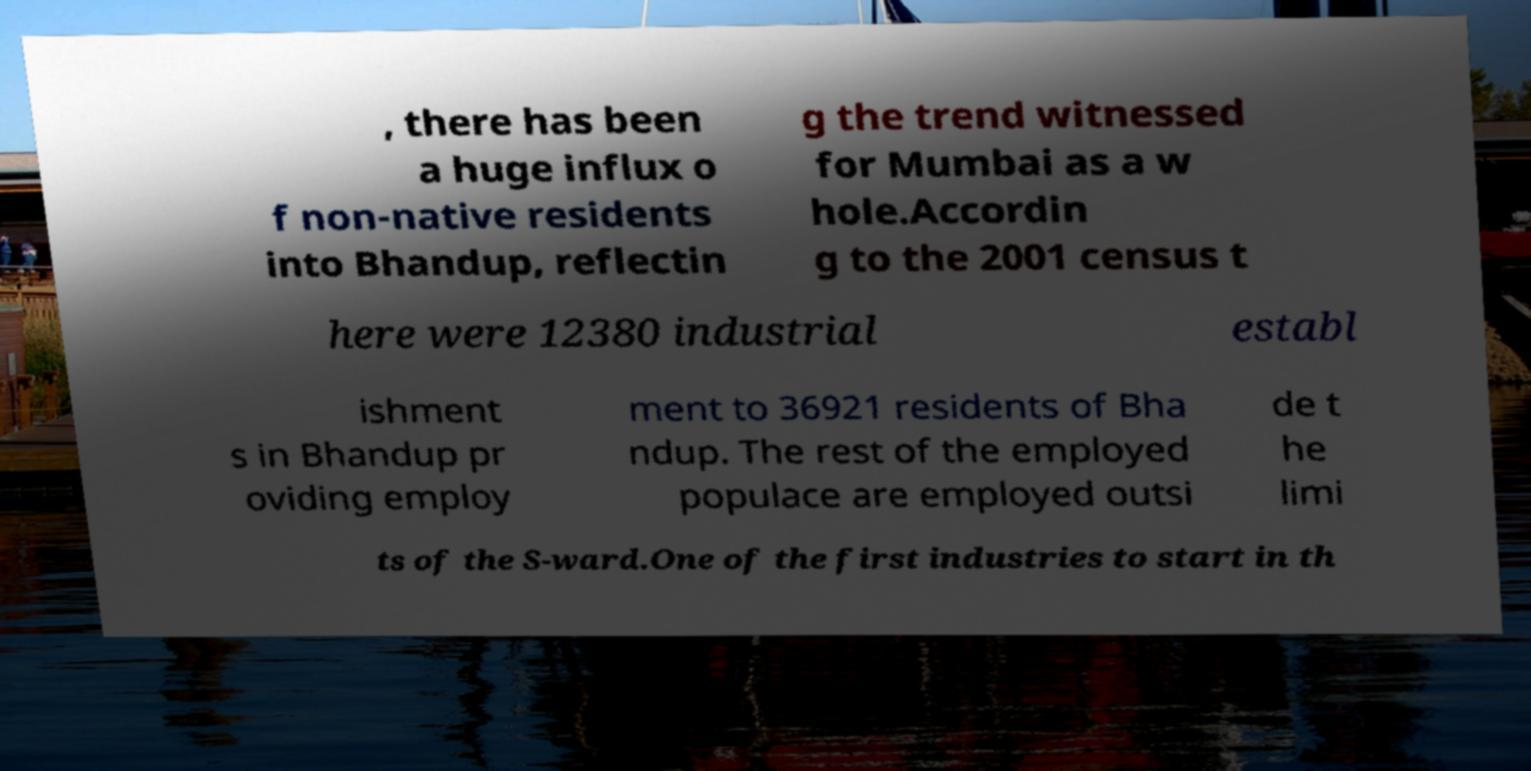I need the written content from this picture converted into text. Can you do that? , there has been a huge influx o f non-native residents into Bhandup, reflectin g the trend witnessed for Mumbai as a w hole.Accordin g to the 2001 census t here were 12380 industrial establ ishment s in Bhandup pr oviding employ ment to 36921 residents of Bha ndup. The rest of the employed populace are employed outsi de t he limi ts of the S-ward.One of the first industries to start in th 